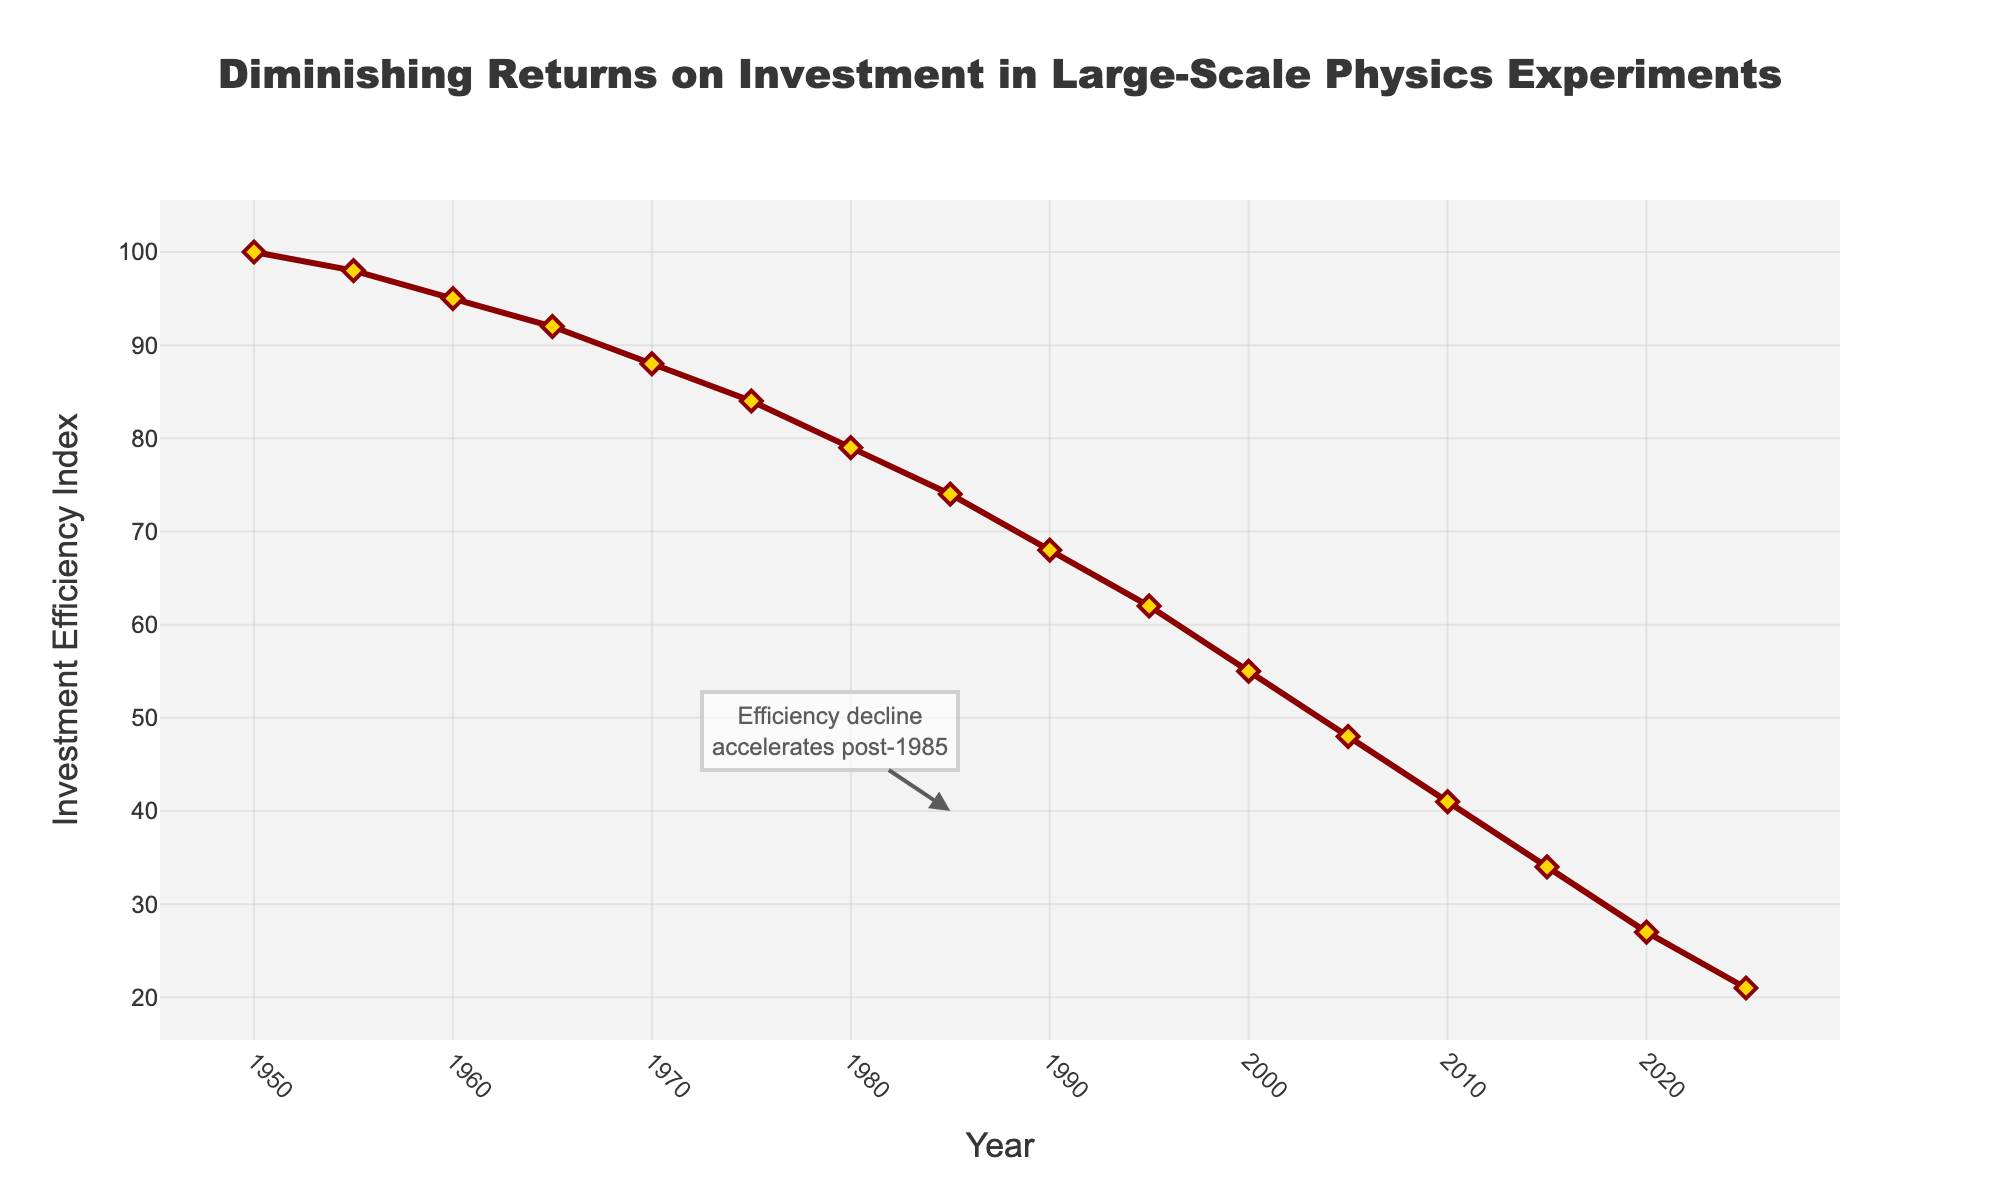What's the earliest year where the Investment Efficiency Index is below 50? Check the x-axis for the year and see where the y-axis value drops below 50. This occurs at the year 2005.
Answer: 2005 Which year has the highest Investment Efficiency Index value? Look at the starting point on the chart and note the highest y-axis value, which is 100, occurring in the year 1950.
Answer: 1950 How many years are covered in the data from the figure? Count the intervals on the x-axis from 1950 to 2025, marking each data point. Calculation: 2025 - 1950 = 75 years.
Answer: 75 years What is the approximate reduction in efficiency from 1985 to 2020? Compare the y-values at 1985 (74) and 2020 (27), then find the difference: 74 - 27 = 47.
Answer: 47 By how much does the Investment Efficiency Index decrease on average every decade from 1950 to 2025? Calculate: (1950-2025 = 75 years, 75/10 = 7.5 decades). 
Find the total drop: 100 - 21 = 79. 
79/7.5 = 10.53 (approx) per decade.
Answer: ~10.53 per decade In which year does the auto-annotated text "Efficiency decline accelerates" appear? Analyze the position of the annotation on the x-axis, labeled directly at the year 1985.
Answer: 1985 Is the Investment Efficiency Index above or below 50 in the year 2000? Check the y-axis value at the year 2000, which is noted as 55 (above 50).
Answer: Above 50 Which period shows a steeper decline in Investment Efficiency Index: 1950 to 1980 or 1980 to 2010? Assess the y-axis drop in both periods: 
- 1950 to 1980: 100 to 79 (a drop of 21).
- 1980 to 2010: 79 to 41 (a drop of 38).
Since 38 > 21, the period from 1980 to 2010 shows a steeper decline.
Answer: 1980 to 2010 